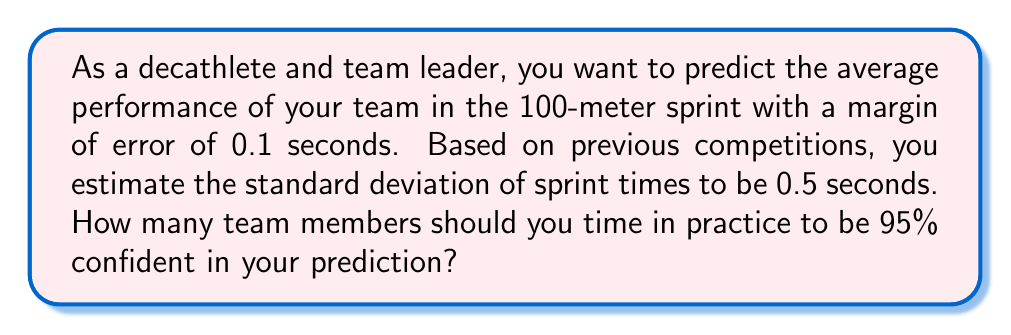Could you help me with this problem? To determine the sample size needed for accurate performance predictions, we'll use the formula for sample size calculation with a known population standard deviation:

$$n = \left(\frac{z\sigma}{E}\right)^2$$

Where:
$n$ = required sample size
$z$ = z-score for the desired confidence level
$\sigma$ = population standard deviation
$E$ = margin of error

Step 1: Identify the known values
- Confidence level: 95% (z-score = 1.96)
- Standard deviation ($\sigma$): 0.5 seconds
- Margin of error ($E$): 0.1 seconds

Step 2: Substitute the values into the formula
$$n = \left(\frac{1.96 \times 0.5}{0.1}\right)^2$$

Step 3: Calculate the result
$$n = (9.8)^2 = 96.04$$

Step 4: Round up to the nearest whole number
Since we can't have a fractional number of team members, we round up to 97.
Answer: 97 team members 